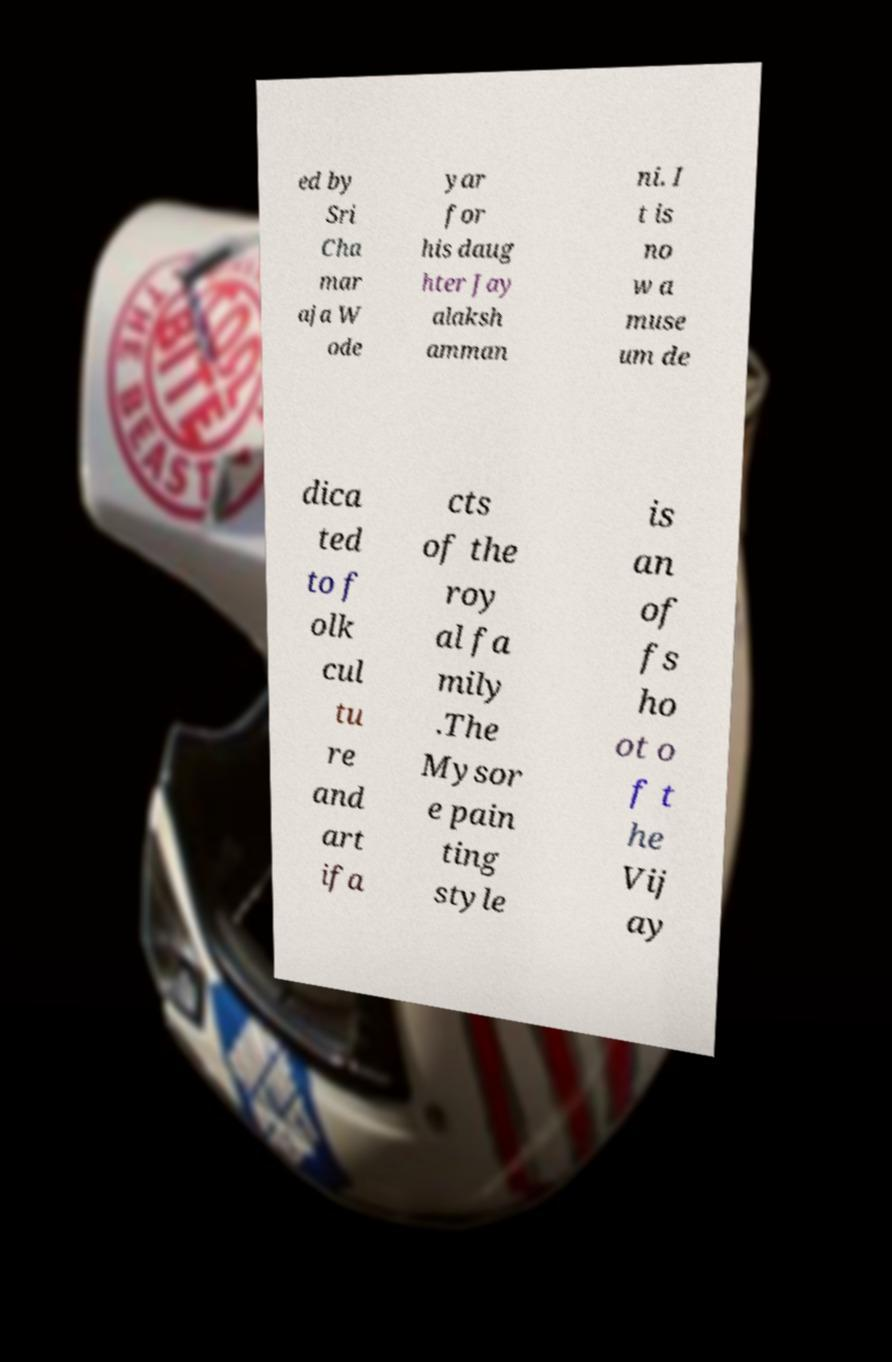Please read and relay the text visible in this image. What does it say? ed by Sri Cha mar aja W ode yar for his daug hter Jay alaksh amman ni. I t is no w a muse um de dica ted to f olk cul tu re and art ifa cts of the roy al fa mily .The Mysor e pain ting style is an of fs ho ot o f t he Vij ay 